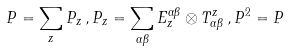<formula> <loc_0><loc_0><loc_500><loc_500>P = \sum _ { z } P _ { z } \, , P _ { z } = \sum _ { \alpha \beta } E ^ { \alpha \beta } _ { z } \otimes T ^ { z } _ { \alpha \beta } \, , P ^ { 2 } = P</formula> 